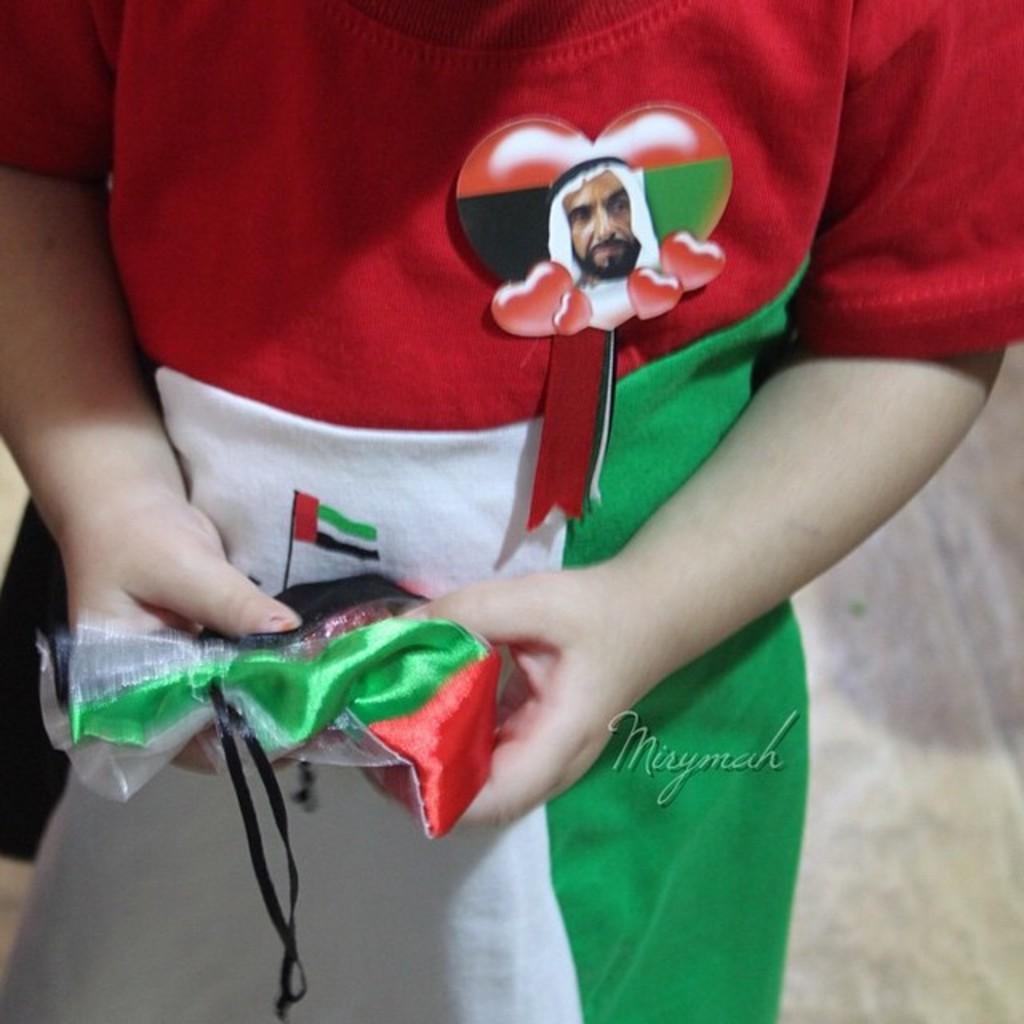What can be seen in the image? There is a person in the image. What distinguishes the person in the image? The person has a badge. What is the person holding in the image? The person is holding an object. How would you describe the background of the image? The background of the image is blurred. Can you identify any additional features of the image? There is a watermark on the image. How many trucks can be seen in the image? There are no trucks visible in the image; it features a person with a badge and an object. What type of footwear is the mom wearing in the image? There is no mom present in the image, and therefore no footwear can be observed. 